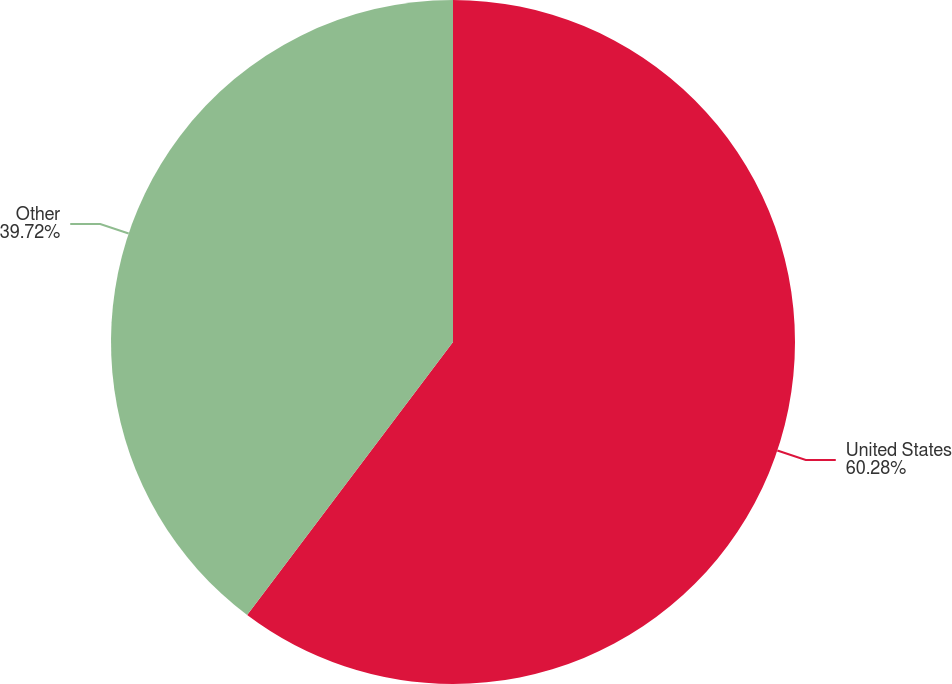<chart> <loc_0><loc_0><loc_500><loc_500><pie_chart><fcel>United States<fcel>Other<nl><fcel>60.28%<fcel>39.72%<nl></chart> 